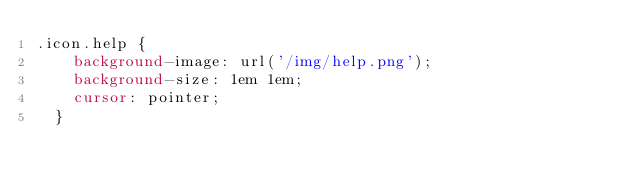<code> <loc_0><loc_0><loc_500><loc_500><_CSS_>.icon.help {
    background-image: url('/img/help.png');
    background-size: 1em 1em;
    cursor: pointer;
  }
</code> 